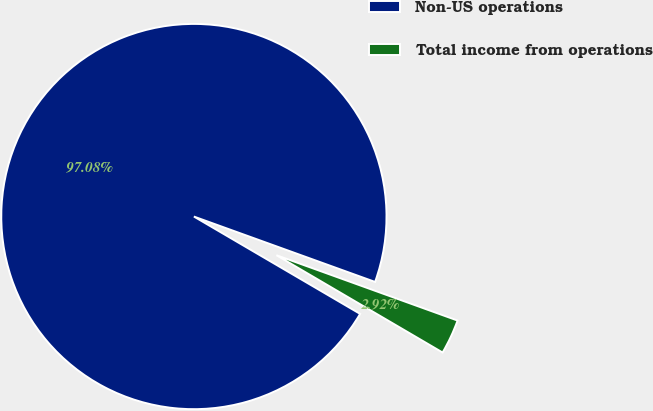Convert chart. <chart><loc_0><loc_0><loc_500><loc_500><pie_chart><fcel>Non-US operations<fcel>Total income from operations<nl><fcel>97.08%<fcel>2.92%<nl></chart> 